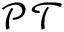<formula> <loc_0><loc_0><loc_500><loc_500>\mathcal { P } \mathcal { T }</formula> 